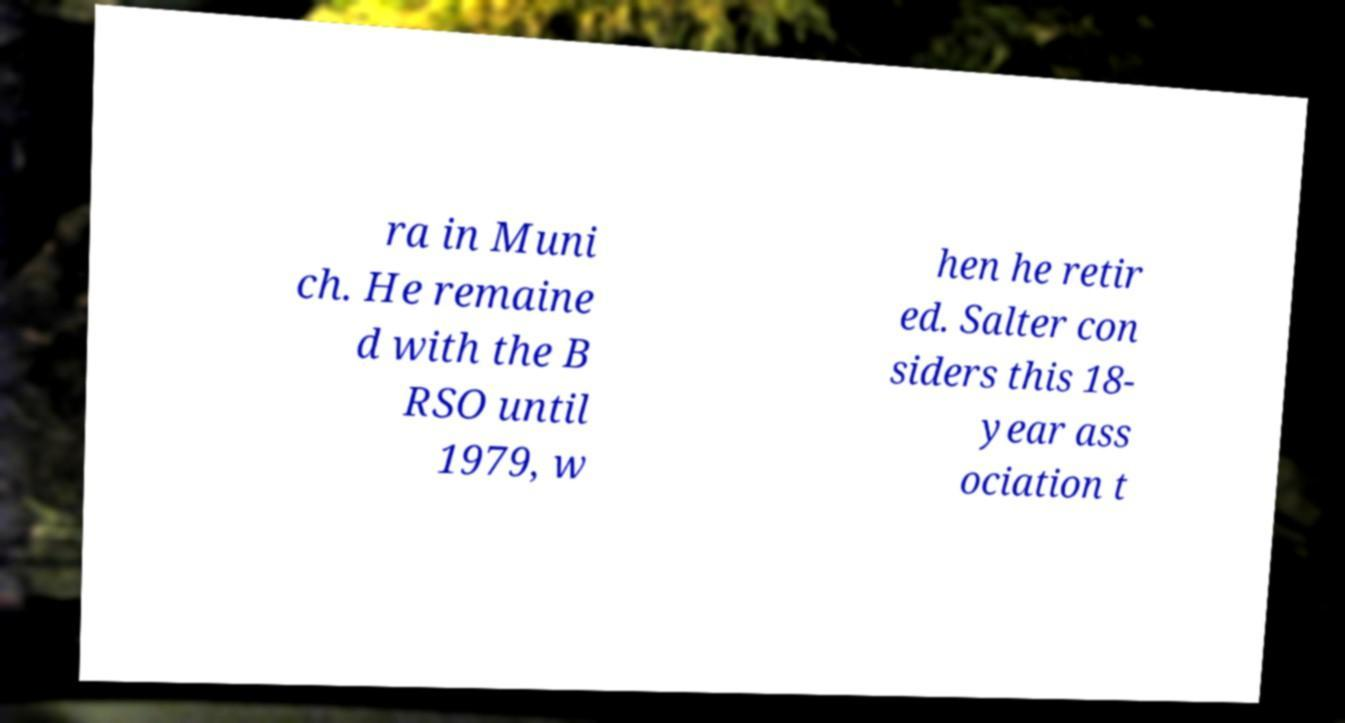For documentation purposes, I need the text within this image transcribed. Could you provide that? ra in Muni ch. He remaine d with the B RSO until 1979, w hen he retir ed. Salter con siders this 18- year ass ociation t 